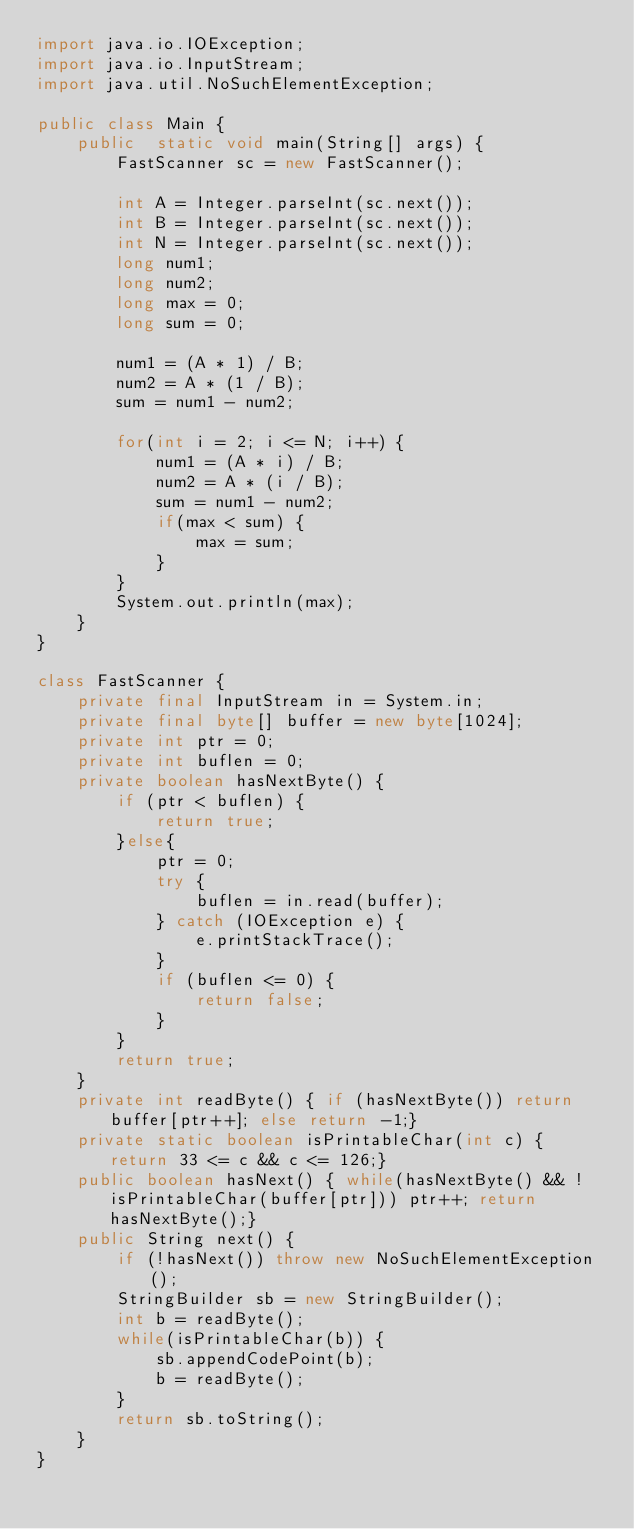Convert code to text. <code><loc_0><loc_0><loc_500><loc_500><_Java_>import java.io.IOException;
import java.io.InputStream;
import java.util.NoSuchElementException;

public class Main {
    public  static void main(String[] args) {
        FastScanner sc = new FastScanner();

        int A = Integer.parseInt(sc.next());
        int B = Integer.parseInt(sc.next());
        int N = Integer.parseInt(sc.next());
        long num1;
        long num2;
        long max = 0;
        long sum = 0;

        num1 = (A * 1) / B;
    	num2 = A * (1 / B);
    	sum = num1 - num2;

        for(int i = 2; i <= N; i++) {
        	num1 = (A * i) / B;
        	num2 = A * (i / B);
        	sum = num1 - num2;
        	if(max < sum) {
        		max = sum;
        	}
        }
        System.out.println(max);
    }
}

class FastScanner {
    private final InputStream in = System.in;
    private final byte[] buffer = new byte[1024];
    private int ptr = 0;
    private int buflen = 0;
    private boolean hasNextByte() {
        if (ptr < buflen) {
            return true;
        }else{
            ptr = 0;
            try {
                buflen = in.read(buffer);
            } catch (IOException e) {
                e.printStackTrace();
            }
            if (buflen <= 0) {
                return false;
            }
        }
        return true;
    }
    private int readByte() { if (hasNextByte()) return buffer[ptr++]; else return -1;}
    private static boolean isPrintableChar(int c) { return 33 <= c && c <= 126;}
    public boolean hasNext() { while(hasNextByte() && !isPrintableChar(buffer[ptr])) ptr++; return hasNextByte();}
    public String next() {
        if (!hasNext()) throw new NoSuchElementException();
        StringBuilder sb = new StringBuilder();
        int b = readByte();
        while(isPrintableChar(b)) {
            sb.appendCodePoint(b);
            b = readByte();
        }
        return sb.toString();
    }
}</code> 